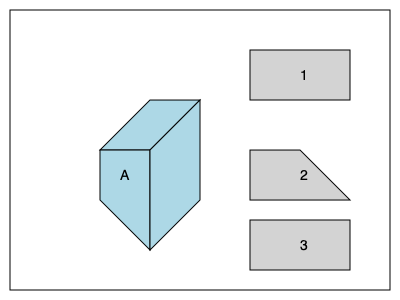Your child is working on a 3D geometry project for their AEC (Architecture, Engineering, and Construction) class. They need to match the 3D object labeled 'A' with its correct 2D shadow projection. Which of the numbered projections (1, 2, or 3) is the correct shadow when the object is viewed from directly above? To solve this problem, we need to analyze the 3D object and imagine how it would look when viewed from directly above. Let's break it down step-by-step:

1. Observe the 3D object (A):
   - It has a square top face
   - Two vertical faces and one slanted face

2. Imagine viewing the object from directly above:
   - We would see only the top square face
   - The vertical and slanted faces would not be visible in this view

3. Examine the shadow projections:
   - Projection 1: A rectangle
   - Projection 2: A trapezoid
   - Projection 3: A square

4. Compare the imagined top view with the given projections:
   - The top view of the object is a square
   - Only projection 3 matches this shape

Therefore, the correct 2D shadow projection when viewed from directly above is projection 3.
Answer: 3 